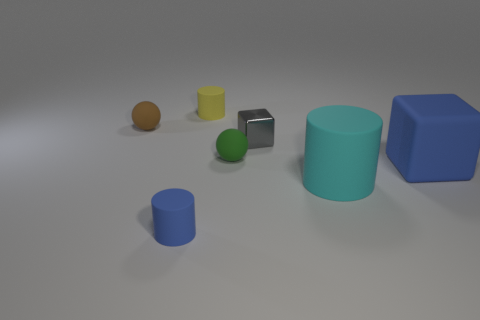Add 1 tiny cyan metal cubes. How many objects exist? 8 Subtract all tiny cylinders. How many cylinders are left? 1 Subtract 1 balls. How many balls are left? 1 Subtract all purple cylinders. Subtract all blue spheres. How many cylinders are left? 3 Subtract all gray cylinders. How many purple spheres are left? 0 Subtract all tiny brown blocks. Subtract all large cyan matte cylinders. How many objects are left? 6 Add 7 tiny matte balls. How many tiny matte balls are left? 9 Add 1 tiny cyan cylinders. How many tiny cyan cylinders exist? 1 Subtract all blue cubes. How many cubes are left? 1 Subtract 1 cyan cylinders. How many objects are left? 6 